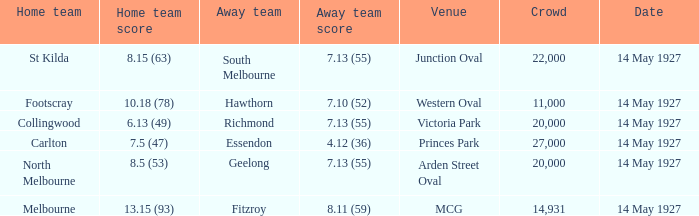When richmond had an away score of 7.13 (55), what was the combined attendance of all crowds? 20000.0. 